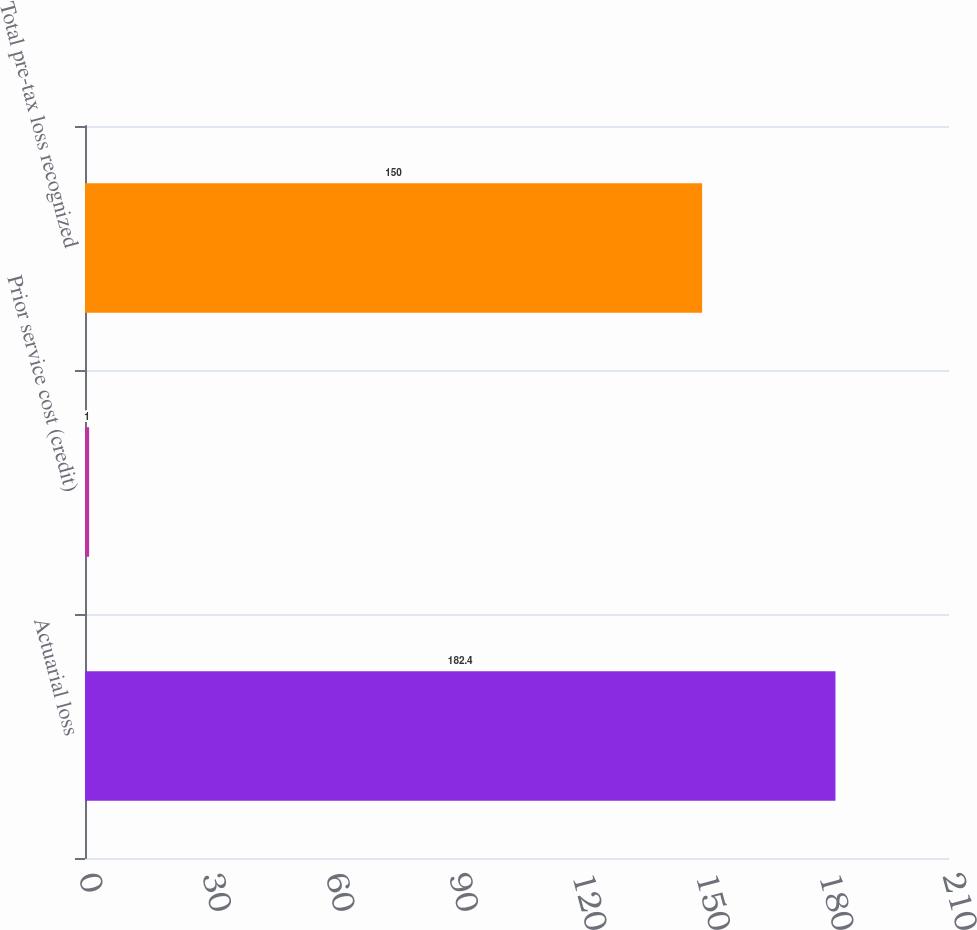<chart> <loc_0><loc_0><loc_500><loc_500><bar_chart><fcel>Actuarial loss<fcel>Prior service cost (credit)<fcel>Total pre-tax loss recognized<nl><fcel>182.4<fcel>1<fcel>150<nl></chart> 